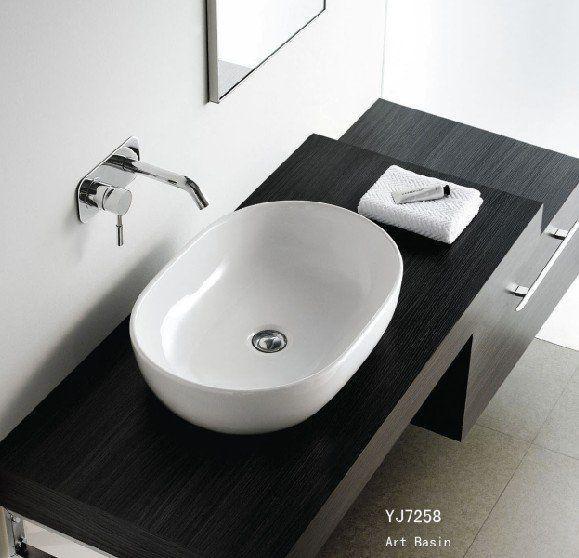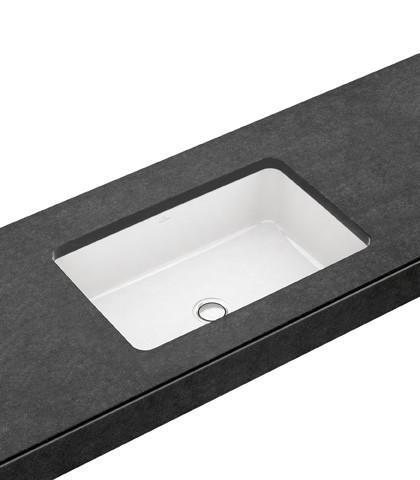The first image is the image on the left, the second image is the image on the right. Examine the images to the left and right. Is the description "There are two oval shaped sinks installed in countertops." accurate? Answer yes or no. No. 